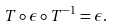<formula> <loc_0><loc_0><loc_500><loc_500>T \circ \epsilon \circ T ^ { - 1 } = \epsilon .</formula> 